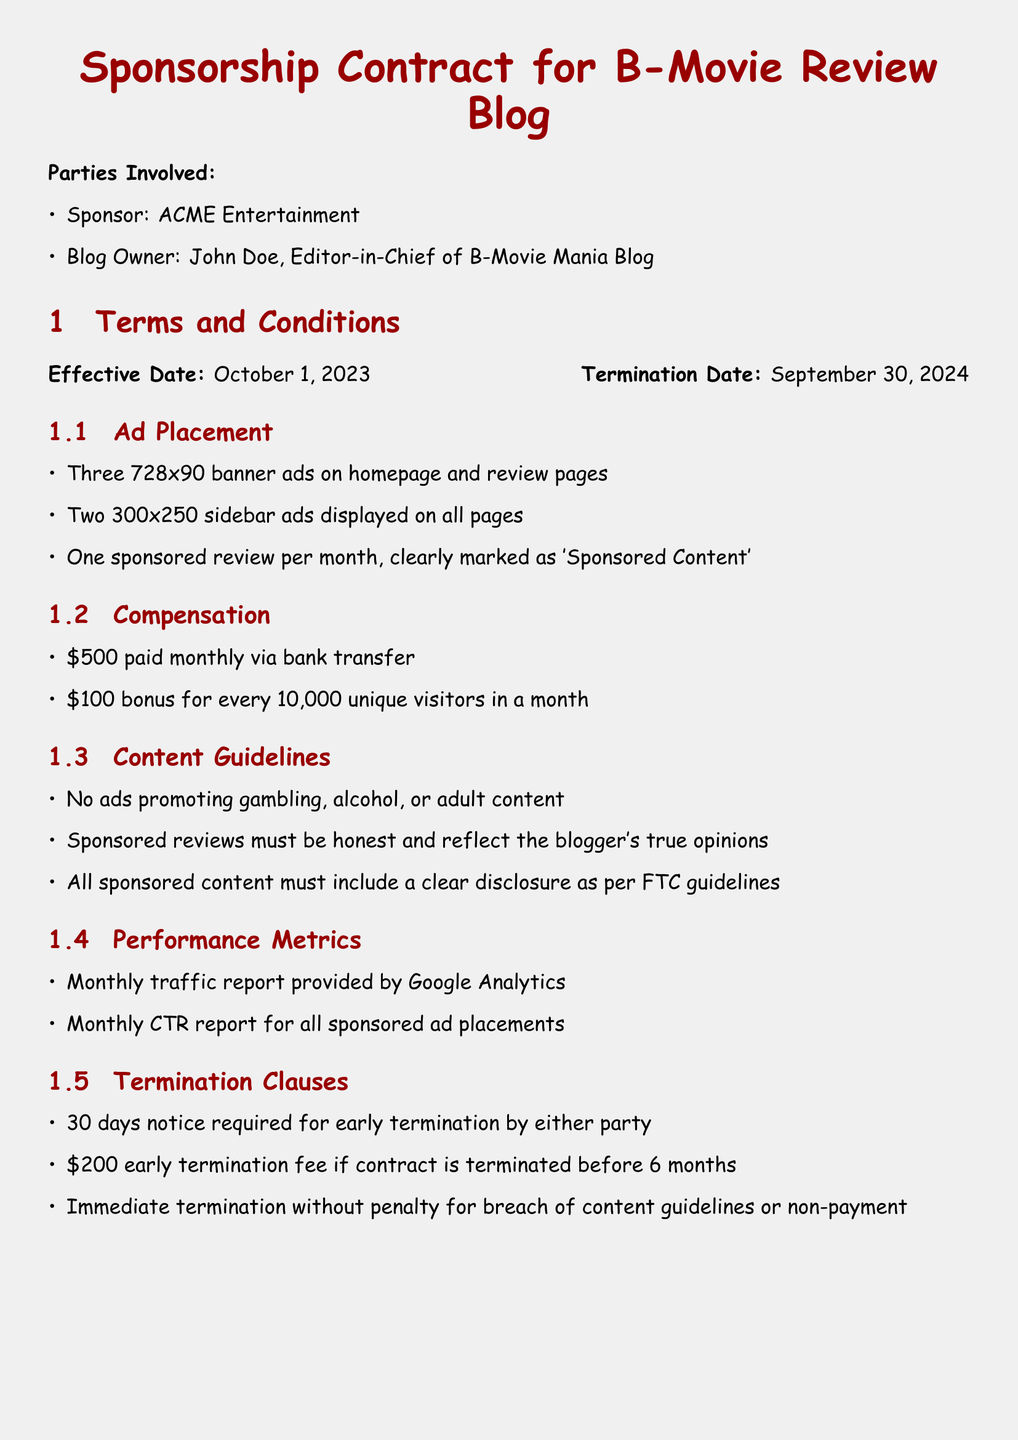What is the name of the sponsor? The sponsor is ACME Entertainment, as stated in the "Parties Involved" section.
Answer: ACME Entertainment What is the effective date of the contract? The effective date is mentioned in the "Terms and Conditions" section as October 1, 2023.
Answer: October 1, 2023 How many monthly sponsored reviews are required? The document specifies one sponsored review per month in the "Ad Placement" section.
Answer: One What is the penalty for early termination before six months? The "Termination Clauses" section states that there is a $200 early termination fee.
Answer: $200 What is the compensation paid monthly? The compensation listed in the "Compensation" section is $500 paid monthly via bank transfer.
Answer: $500 What type of content cannot be advertised? The "Content Guidelines" section prohibits ads promoting gambling, alcohol, or adult content.
Answer: Gambling, alcohol, adult content Who is the Marketing Director of the sponsor? The "Sponsor Representative" section lists Jane Smith as the Marketing Director.
Answer: Jane Smith What is required for early termination notice? The "Termination Clauses" section requires a 30 days notice for early termination.
Answer: 30 days Which law governs this contract? The "Miscellaneous" section indicates that this contract is governed by the laws of the State of California.
Answer: State of California 